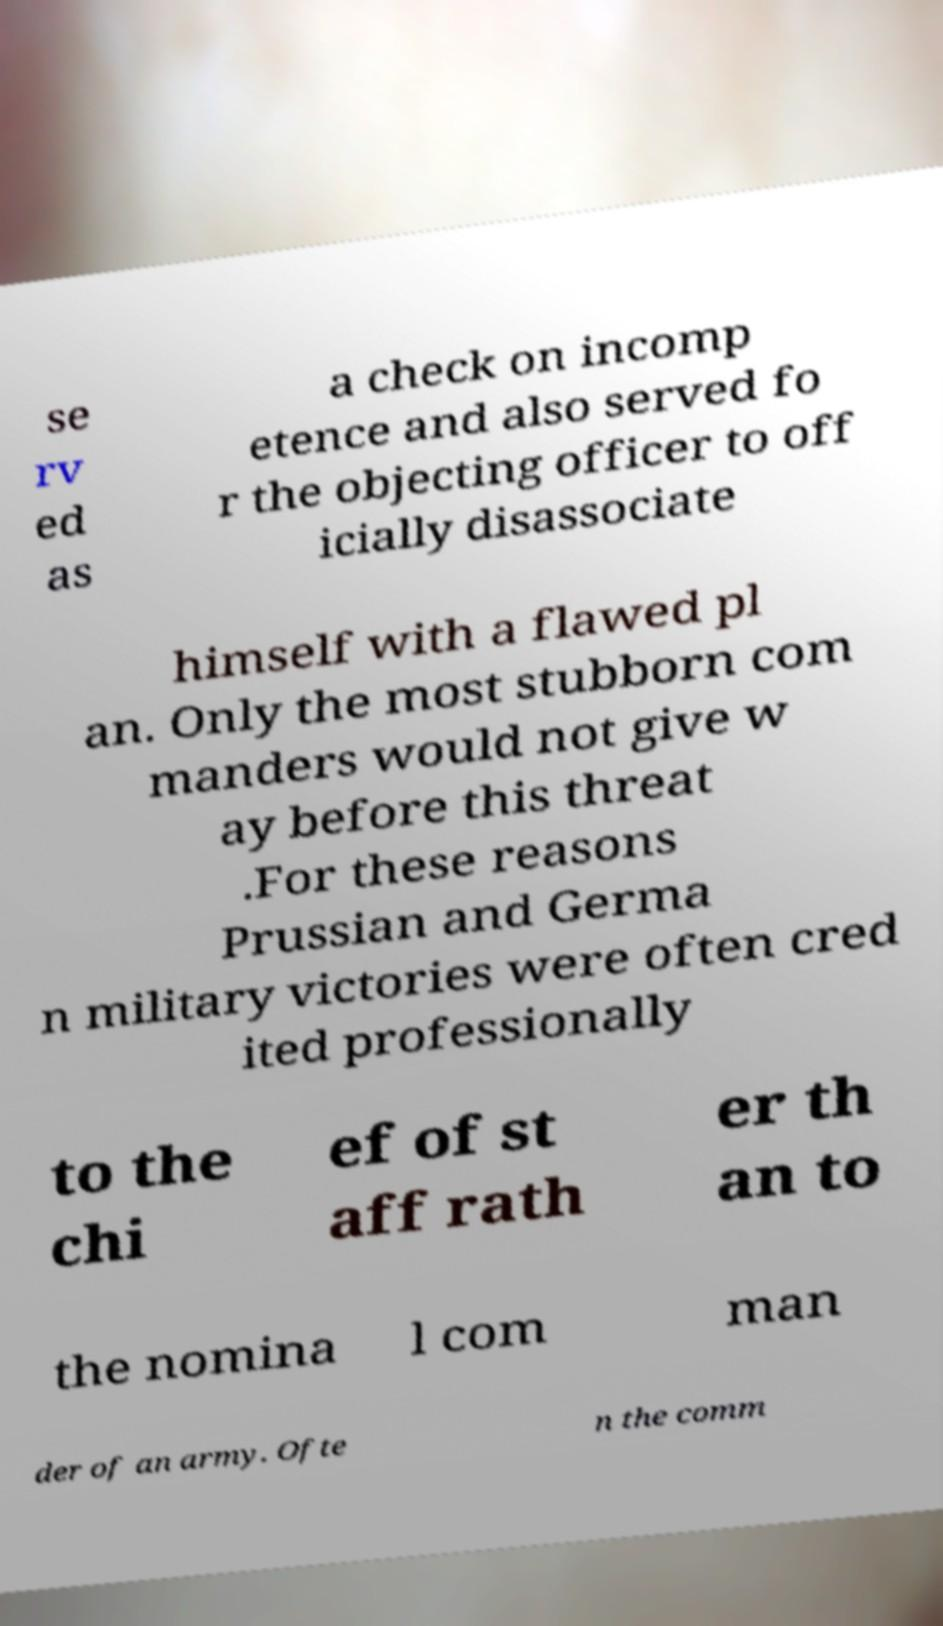Can you read and provide the text displayed in the image?This photo seems to have some interesting text. Can you extract and type it out for me? se rv ed as a check on incomp etence and also served fo r the objecting officer to off icially disassociate himself with a flawed pl an. Only the most stubborn com manders would not give w ay before this threat .For these reasons Prussian and Germa n military victories were often cred ited professionally to the chi ef of st aff rath er th an to the nomina l com man der of an army. Ofte n the comm 